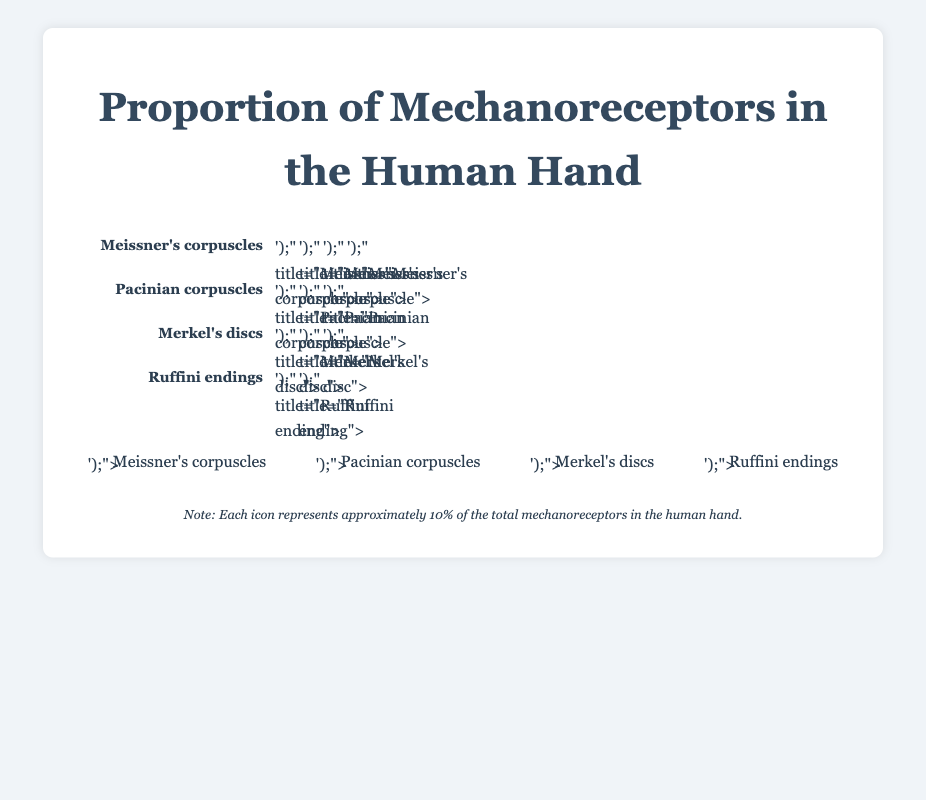How many types of mechanoreceptors are illustrated in the figure? The figure shows four distinct types of mechanoreceptors: Meissner's corpuscles, Pacinian corpuscles, Merkel's discs, and Ruffini endings.
Answer: 4 Which mechanoreceptor type is the most abundant in the human hand according to the figure? The figure shows that Meissner's corpuscles have the highest number of icons (40), indicating they are the most abundant type.
Answer: Meissner's corpuscles Compare the count of Pacinian corpuscles to Ruffini endings. Which is greater? The figure shows 25 icons for Pacinian corpuscles and 15 icons for Ruffini endings. Therefore, Pacinian corpuscles are more abundant.
Answer: Pacinian corpuscles What percentage of the mechanoreceptors are Merkel's discs? Merkel's discs have 30 icons out of a total of 110 (40+25+30+15). The percentage is (30/110) * 100 = 27.27%.
Answer: 27.27% Compare the function of Meissner's corpuscles to Pacinian corpuscles based on the figure. The figure states that Meissner's corpuscles are responsible for light touch sensation, while Pacinian corpuscles are responsible for pressure and vibration.
Answer: Meissner's corpuscles: light touch, Pacinian corpuscles: pressure and vibration How does the location of Ruffini endings differ from Merkel's discs? According to the figure, Ruffini endings are located in the dermis, while Merkel's discs are found in the basal epidermis.
Answer: Ruffini endings: dermis, Merkel's discs: basal epidermis What is the total count of mechanoreceptors depicted in the figure? The total count is the sum of all the types: 40 (Meissner's corpuscles) + 25 (Pacinian corpuscles) + 30 (Merkel's discs) + 15 (Ruffini endings). The total is 110.
Answer: 110 Calculate the difference in the count between the most and the least abundant mechanoreceptors. The most abundant (Meissner's corpuscles) have 40 icons, and the least abundant (Ruffini endings) have 15 icons. The difference is 40 - 15 = 25.
Answer: 25 According to the figure, which mechanoreceptor is responsible for skin stretch? The figure labels Ruffini endings as the mechanoreceptor responsible for sensing skin stretch.
Answer: Ruffini endings Based on the figure, how are the icons representing each mechanoreceptor type visually differentiated? Different shapes and colors represent each type: circles for Meissner's corpuscles (red), rectangles for Pacinian corpuscles (teal), triangles for Merkel's discs (yellow), and ellipses for Ruffini endings (purple).
Answer: Different shapes and colors 